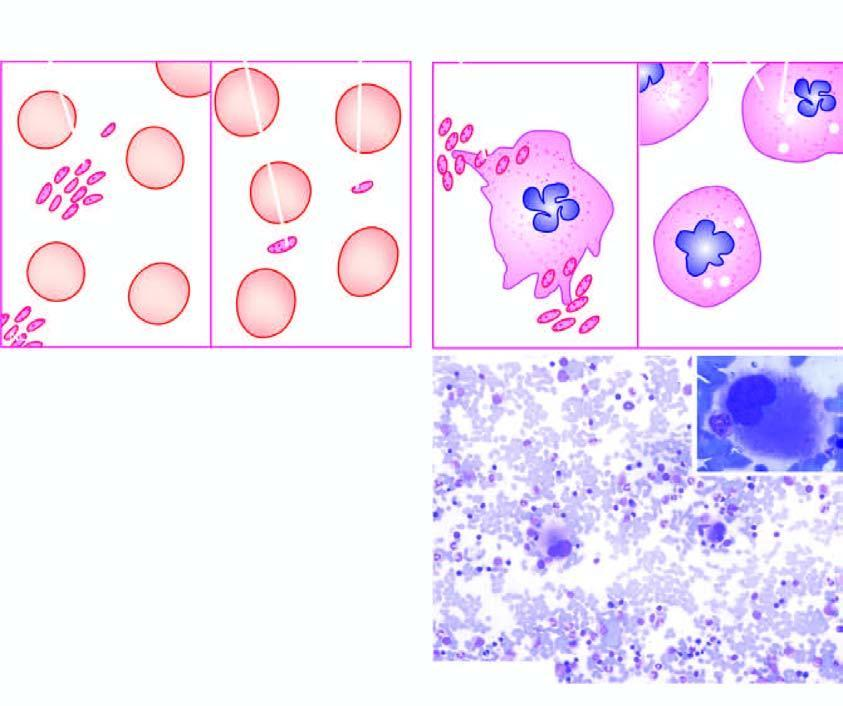what is laboratory findings of itp contrasted with?
Answer the question using a single word or phrase. Those found normal individual 